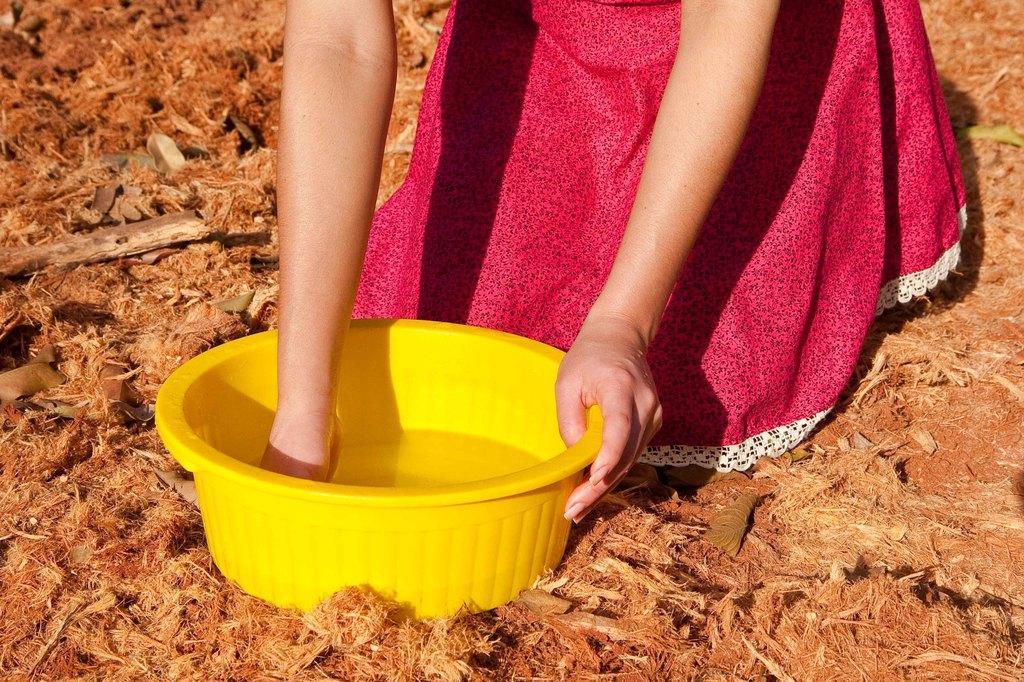How would you summarize this image in a sentence or two? In this picture there is a water tub on the floor and there is a lady at the top side of the image. 